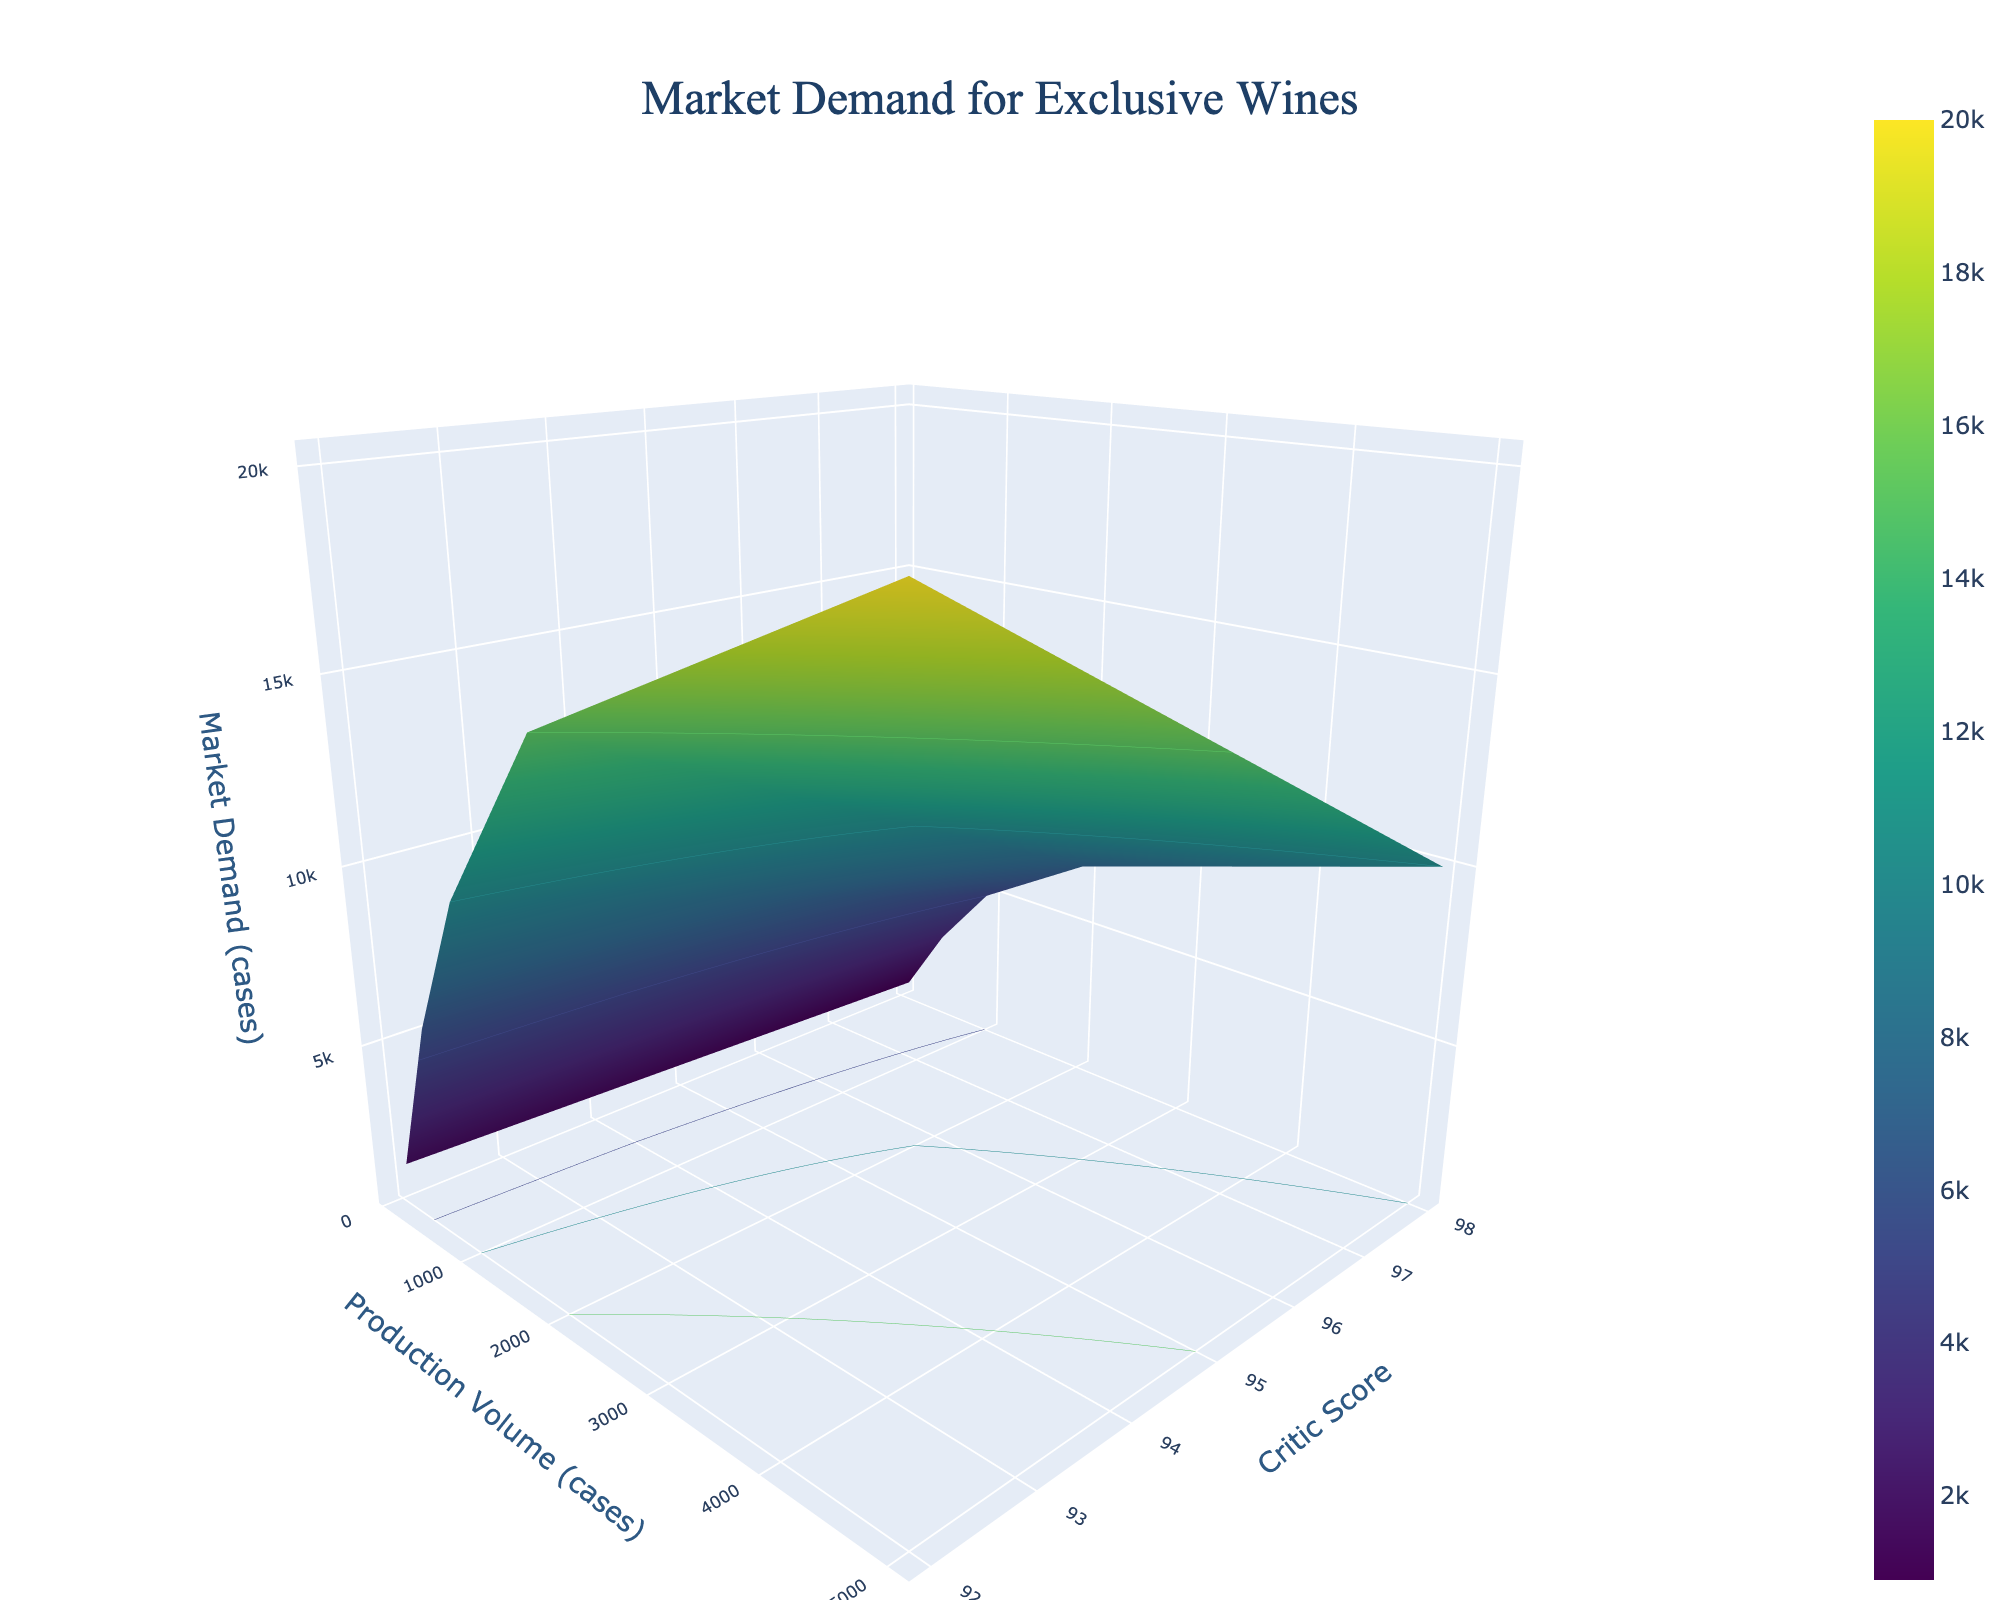What's the title of the plot? The title is displayed at the top of the plot, formatted in a large size and positioned centrally. It reads "Market Demand for Exclusive Wines".
Answer: Market Demand for Exclusive Wines What does the color scale represent in the plot? The color scale represents the values of Market Demand in cases, with different colors indicating different levels of demand.
Answer: Market Demand Which axis represents the Production Volume? The x-axis represents Production Volume, as indicated by the title "Production Volume (cases)" along this axis.
Answer: x-axis At which Critic Score does the Market Demand peak for a Production Volume of 2000 cases? To find the peak Market Demand, look under 2000 cases on the x-axis and move across the different Critic Scores on the y-axis. The highest Market Demand color intensity is at a Critic Score of 98.
Answer: 98 How does the Market Demand change as the Critic Score increases for a fixed Production Volume of 5000 cases? Observe the Market Demand values along the x-axis for 5000 cases and note the trend as Critic Scores vary. Demand increases with a higher Critic Score.
Answer: Increases Which combination of Critic Score and Production Volume shows the lowest Market Demand? Search for the lowest color intensity on the surface plot, then cross-reference this with the axes. The lowest Market Demand is for 100 cases and a Critic Score of 92.
Answer: 100 cases and 92 For a Production Volume of 1000 cases, what is the difference in Market Demand between Critic Scores of 98 and 92? Observe the Market Demand values at 1000 cases for both Critic Scores of 98 and 92. The difference is 10000 - 5000 = 5000 cases.
Answer: 5000 cases Is there a noticeable trend in Market Demand as Production Volume increases from 100 to 5000 cases for a Critic Score of 95? Analyze the plot for Critic Score of 95 as Production Volume changes from 100 to 5000 cases. Market Demand consistently increases.
Answer: Increases 